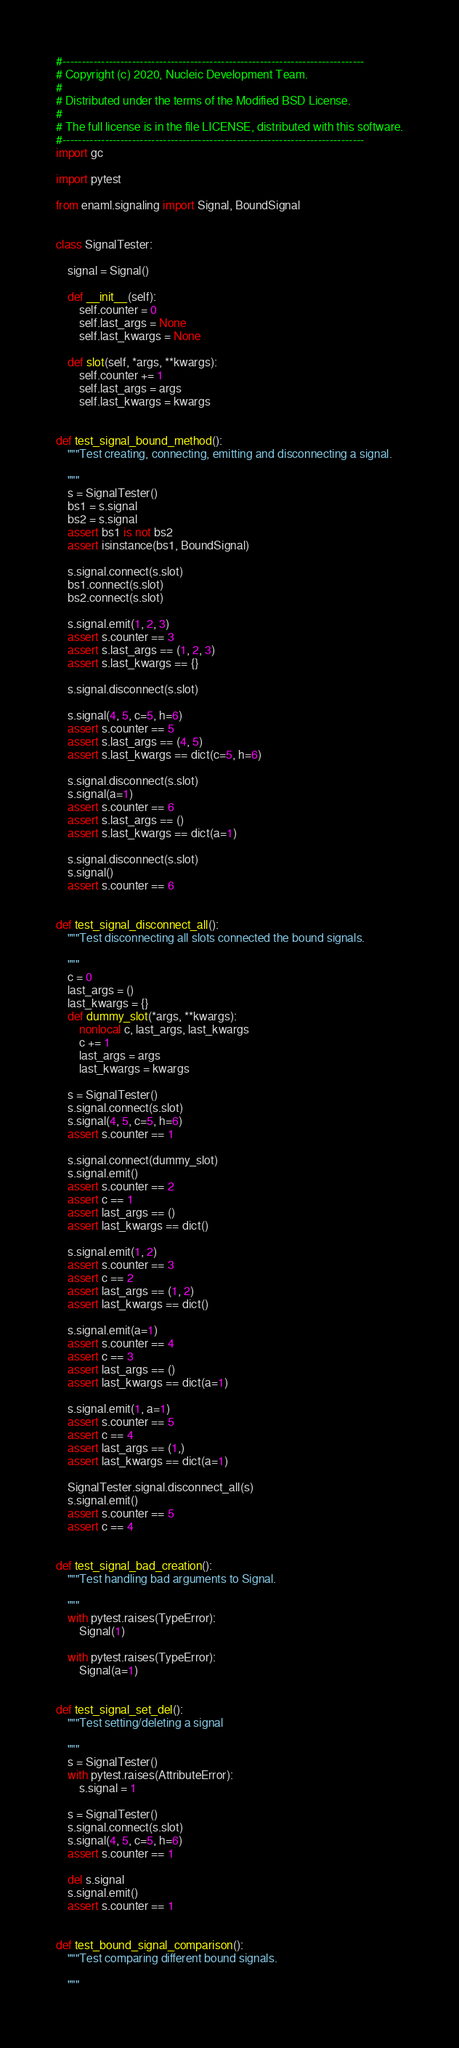<code> <loc_0><loc_0><loc_500><loc_500><_Python_>#------------------------------------------------------------------------------
# Copyright (c) 2020, Nucleic Development Team.
#
# Distributed under the terms of the Modified BSD License.
#
# The full license is in the file LICENSE, distributed with this software.
#------------------------------------------------------------------------------
import gc

import pytest

from enaml.signaling import Signal, BoundSignal


class SignalTester:

    signal = Signal()

    def __init__(self):
        self.counter = 0
        self.last_args = None
        self.last_kwargs = None

    def slot(self, *args, **kwargs):
        self.counter += 1
        self.last_args = args
        self.last_kwargs = kwargs


def test_signal_bound_method():
    """Test creating, connecting, emitting and disconnecting a signal.

    """
    s = SignalTester()
    bs1 = s.signal
    bs2 = s.signal
    assert bs1 is not bs2
    assert isinstance(bs1, BoundSignal)

    s.signal.connect(s.slot)
    bs1.connect(s.slot)
    bs2.connect(s.slot)

    s.signal.emit(1, 2, 3)
    assert s.counter == 3
    assert s.last_args == (1, 2, 3)
    assert s.last_kwargs == {}

    s.signal.disconnect(s.slot)

    s.signal(4, 5, c=5, h=6)
    assert s.counter == 5
    assert s.last_args == (4, 5)
    assert s.last_kwargs == dict(c=5, h=6)

    s.signal.disconnect(s.slot)
    s.signal(a=1)
    assert s.counter == 6
    assert s.last_args == ()
    assert s.last_kwargs == dict(a=1)

    s.signal.disconnect(s.slot)
    s.signal()
    assert s.counter == 6


def test_signal_disconnect_all():
    """Test disconnecting all slots connected the bound signals.

    """
    c = 0
    last_args = ()
    last_kwargs = {}
    def dummy_slot(*args, **kwargs):
        nonlocal c, last_args, last_kwargs
        c += 1
        last_args = args
        last_kwargs = kwargs

    s = SignalTester()
    s.signal.connect(s.slot)
    s.signal(4, 5, c=5, h=6)
    assert s.counter == 1

    s.signal.connect(dummy_slot)
    s.signal.emit()
    assert s.counter == 2
    assert c == 1
    assert last_args == ()
    assert last_kwargs == dict()

    s.signal.emit(1, 2)
    assert s.counter == 3
    assert c == 2
    assert last_args == (1, 2)
    assert last_kwargs == dict()

    s.signal.emit(a=1)
    assert s.counter == 4
    assert c == 3
    assert last_args == ()
    assert last_kwargs == dict(a=1)

    s.signal.emit(1, a=1)
    assert s.counter == 5
    assert c == 4
    assert last_args == (1,)
    assert last_kwargs == dict(a=1)

    SignalTester.signal.disconnect_all(s)
    s.signal.emit()
    assert s.counter == 5
    assert c == 4


def test_signal_bad_creation():
    """Test handling bad arguments to Signal.

    """
    with pytest.raises(TypeError):
        Signal(1)

    with pytest.raises(TypeError):
        Signal(a=1)


def test_signal_set_del():
    """Test setting/deleting a signal

    """
    s = SignalTester()
    with pytest.raises(AttributeError):
        s.signal = 1

    s = SignalTester()
    s.signal.connect(s.slot)
    s.signal(4, 5, c=5, h=6)
    assert s.counter == 1

    del s.signal
    s.signal.emit()
    assert s.counter == 1


def test_bound_signal_comparison():
    """Test comparing different bound signals.

    """</code> 